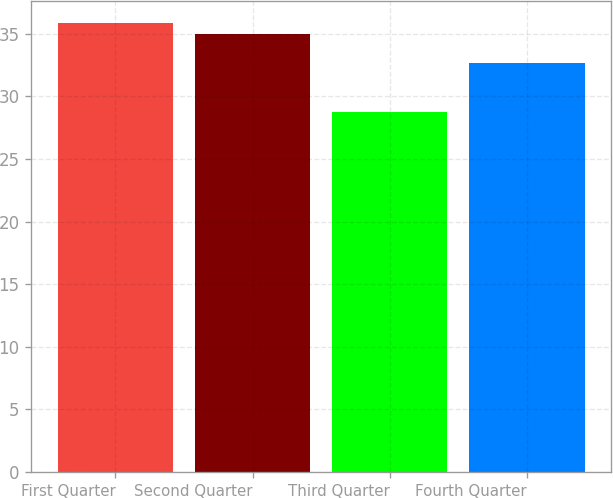Convert chart to OTSL. <chart><loc_0><loc_0><loc_500><loc_500><bar_chart><fcel>First Quarter<fcel>Second Quarter<fcel>Third Quarter<fcel>Fourth Quarter<nl><fcel>35.81<fcel>35<fcel>28.76<fcel>32.66<nl></chart> 